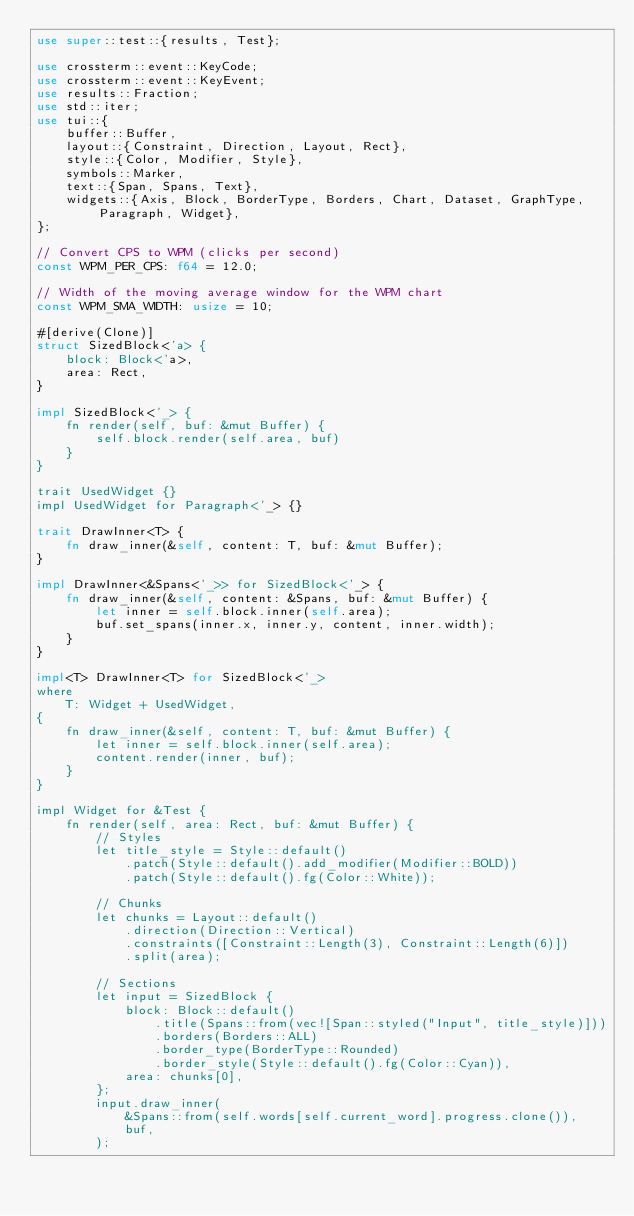Convert code to text. <code><loc_0><loc_0><loc_500><loc_500><_Rust_>use super::test::{results, Test};

use crossterm::event::KeyCode;
use crossterm::event::KeyEvent;
use results::Fraction;
use std::iter;
use tui::{
    buffer::Buffer,
    layout::{Constraint, Direction, Layout, Rect},
    style::{Color, Modifier, Style},
    symbols::Marker,
    text::{Span, Spans, Text},
    widgets::{Axis, Block, BorderType, Borders, Chart, Dataset, GraphType, Paragraph, Widget},
};

// Convert CPS to WPM (clicks per second)
const WPM_PER_CPS: f64 = 12.0;

// Width of the moving average window for the WPM chart
const WPM_SMA_WIDTH: usize = 10;

#[derive(Clone)]
struct SizedBlock<'a> {
    block: Block<'a>,
    area: Rect,
}

impl SizedBlock<'_> {
    fn render(self, buf: &mut Buffer) {
        self.block.render(self.area, buf)
    }
}

trait UsedWidget {}
impl UsedWidget for Paragraph<'_> {}

trait DrawInner<T> {
    fn draw_inner(&self, content: T, buf: &mut Buffer);
}

impl DrawInner<&Spans<'_>> for SizedBlock<'_> {
    fn draw_inner(&self, content: &Spans, buf: &mut Buffer) {
        let inner = self.block.inner(self.area);
        buf.set_spans(inner.x, inner.y, content, inner.width);
    }
}

impl<T> DrawInner<T> for SizedBlock<'_>
where
    T: Widget + UsedWidget,
{
    fn draw_inner(&self, content: T, buf: &mut Buffer) {
        let inner = self.block.inner(self.area);
        content.render(inner, buf);
    }
}

impl Widget for &Test {
    fn render(self, area: Rect, buf: &mut Buffer) {
        // Styles
        let title_style = Style::default()
            .patch(Style::default().add_modifier(Modifier::BOLD))
            .patch(Style::default().fg(Color::White));

        // Chunks
        let chunks = Layout::default()
            .direction(Direction::Vertical)
            .constraints([Constraint::Length(3), Constraint::Length(6)])
            .split(area);

        // Sections
        let input = SizedBlock {
            block: Block::default()
                .title(Spans::from(vec![Span::styled("Input", title_style)]))
                .borders(Borders::ALL)
                .border_type(BorderType::Rounded)
                .border_style(Style::default().fg(Color::Cyan)),
            area: chunks[0],
        };
        input.draw_inner(
            &Spans::from(self.words[self.current_word].progress.clone()),
            buf,
        );</code> 